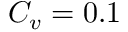Convert formula to latex. <formula><loc_0><loc_0><loc_500><loc_500>C _ { v } = 0 . 1</formula> 